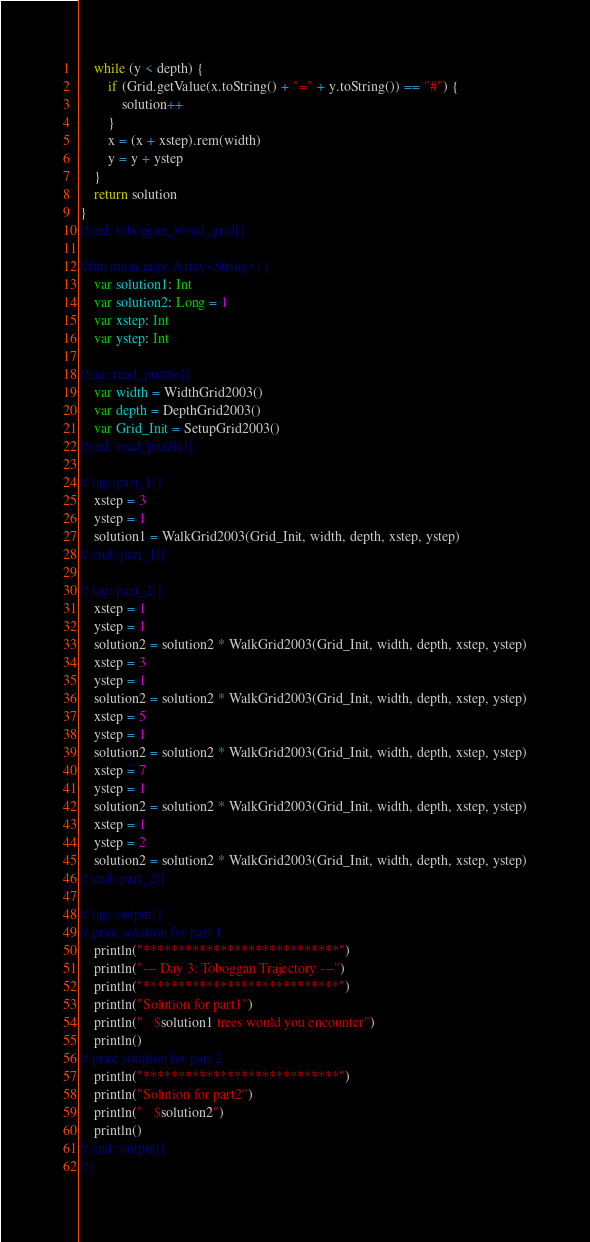<code> <loc_0><loc_0><loc_500><loc_500><_Kotlin_>
	while (y < depth) {
		if (Grid.getValue(x.toString() + "=" + y.toString()) == "#") {
			solution++
		}
		x = (x + xstep).rem(width)
		y = y + ystep
	}
	return solution
}
//end::toboggan_wood_grid[]

//fun main(args: Array<String>) {
	var solution1: Int
	var solution2: Long = 1
	var xstep: Int 
	var ystep: Int 

//tag::read_puzzle[]
	var width = WidthGrid2003()    
	var depth = DepthGrid2003()
	var Grid_Init = SetupGrid2003()
//end::read_puzzle[]

// tag::part_1[]
	xstep = 3
	ystep = 1
	solution1 = WalkGrid2003(Grid_Init, width, depth, xstep, ystep)
// end::part_1[]

// tag::part_2[]
	xstep = 1
	ystep = 1
	solution2 = solution2 * WalkGrid2003(Grid_Init, width, depth, xstep, ystep)
	xstep = 3
	ystep = 1
	solution2 = solution2 * WalkGrid2003(Grid_Init, width, depth, xstep, ystep)
	xstep = 5
	ystep = 1
	solution2 = solution2 * WalkGrid2003(Grid_Init, width, depth, xstep, ystep)
	xstep = 7
	ystep = 1
	solution2 = solution2 * WalkGrid2003(Grid_Init, width, depth, xstep, ystep)
	xstep = 1
	ystep = 2
	solution2 = solution2 * WalkGrid2003(Grid_Init, width, depth, xstep, ystep)
// end::part_2[]

// tag::output[]
// print solution for part 1
	println("****************************")
	println("--- Day 3: Toboggan Trajectory ---")
	println("****************************")
	println("Solution for part1")
	println("   $solution1 trees would you encounter")
	println()
// print solution for part 2
	println("****************************")
	println("Solution for part2")
	println("   $solution2")
	println()
// end::output[]
//}</code> 